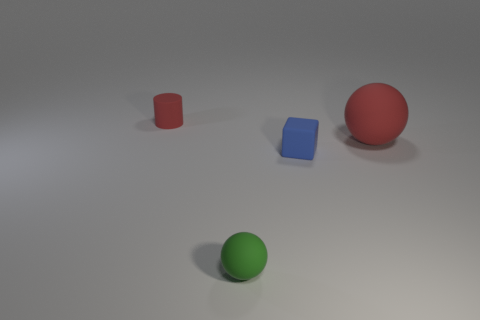Add 4 small brown rubber cylinders. How many objects exist? 8 Subtract all cylinders. How many objects are left? 3 Subtract all big red spheres. Subtract all tiny red things. How many objects are left? 2 Add 3 red rubber cylinders. How many red rubber cylinders are left? 4 Add 3 small blocks. How many small blocks exist? 4 Subtract 0 purple spheres. How many objects are left? 4 